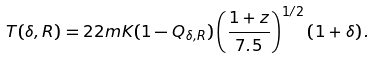<formula> <loc_0><loc_0><loc_500><loc_500>T ( \delta , R ) = 2 2 m K ( 1 - Q _ { \delta , R } ) \left ( \frac { 1 + z } { 7 . 5 } \right ) ^ { 1 / 2 } \left ( 1 + \delta \right ) .</formula> 